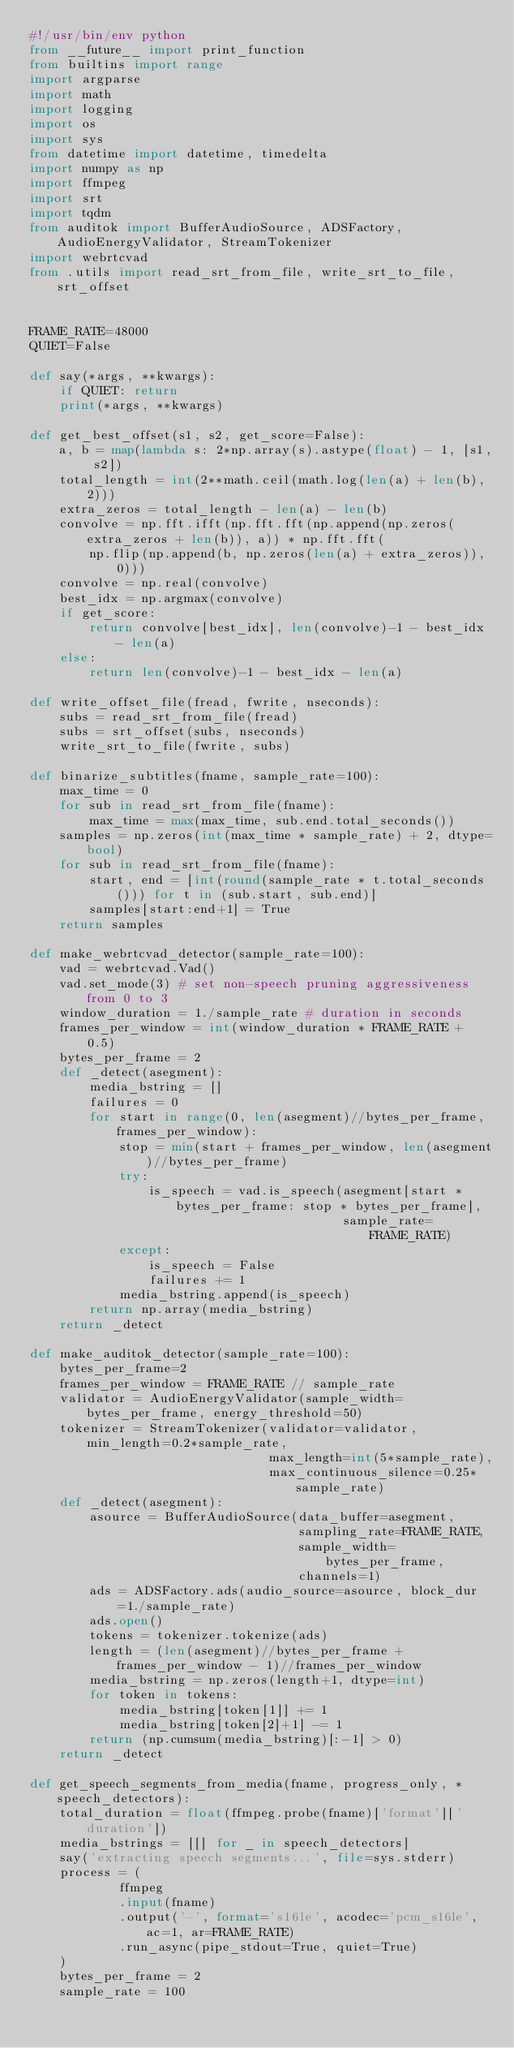Convert code to text. <code><loc_0><loc_0><loc_500><loc_500><_Python_>#!/usr/bin/env python
from __future__ import print_function
from builtins import range
import argparse
import math
import logging
import os
import sys
from datetime import datetime, timedelta
import numpy as np
import ffmpeg
import srt
import tqdm
from auditok import BufferAudioSource, ADSFactory, AudioEnergyValidator, StreamTokenizer
import webrtcvad
from .utils import read_srt_from_file, write_srt_to_file, srt_offset


FRAME_RATE=48000
QUIET=False

def say(*args, **kwargs):
    if QUIET: return
    print(*args, **kwargs)

def get_best_offset(s1, s2, get_score=False):
    a, b = map(lambda s: 2*np.array(s).astype(float) - 1, [s1, s2])
    total_length = int(2**math.ceil(math.log(len(a) + len(b), 2)))
    extra_zeros = total_length - len(a) - len(b)
    convolve = np.fft.ifft(np.fft.fft(np.append(np.zeros(extra_zeros + len(b)), a)) * np.fft.fft(
        np.flip(np.append(b, np.zeros(len(a) + extra_zeros)), 0)))
    convolve = np.real(convolve)
    best_idx = np.argmax(convolve)
    if get_score:
        return convolve[best_idx], len(convolve)-1 - best_idx - len(a)
    else:
        return len(convolve)-1 - best_idx - len(a)

def write_offset_file(fread, fwrite, nseconds):
    subs = read_srt_from_file(fread)
    subs = srt_offset(subs, nseconds)
    write_srt_to_file(fwrite, subs)

def binarize_subtitles(fname, sample_rate=100):
    max_time = 0
    for sub in read_srt_from_file(fname):
        max_time = max(max_time, sub.end.total_seconds())
    samples = np.zeros(int(max_time * sample_rate) + 2, dtype=bool)
    for sub in read_srt_from_file(fname):
        start, end = [int(round(sample_rate * t.total_seconds())) for t in (sub.start, sub.end)]
        samples[start:end+1] = True
    return samples

def make_webrtcvad_detector(sample_rate=100):
    vad = webrtcvad.Vad()
    vad.set_mode(3) # set non-speech pruning aggressiveness from 0 to 3
    window_duration = 1./sample_rate # duration in seconds
    frames_per_window = int(window_duration * FRAME_RATE + 0.5)
    bytes_per_frame = 2
    def _detect(asegment):
        media_bstring = []
        failures = 0
        for start in range(0, len(asegment)//bytes_per_frame, frames_per_window):
            stop = min(start + frames_per_window, len(asegment)//bytes_per_frame)
            try:
                is_speech = vad.is_speech(asegment[start * bytes_per_frame: stop * bytes_per_frame],
                                          sample_rate=FRAME_RATE)
            except:
                is_speech = False
                failures += 1
            media_bstring.append(is_speech)
        return np.array(media_bstring)
    return _detect

def make_auditok_detector(sample_rate=100):
    bytes_per_frame=2
    frames_per_window = FRAME_RATE // sample_rate
    validator = AudioEnergyValidator(sample_width=bytes_per_frame, energy_threshold=50)
    tokenizer = StreamTokenizer(validator=validator, min_length=0.2*sample_rate,
                                max_length=int(5*sample_rate),
                                max_continuous_silence=0.25*sample_rate)
    def _detect(asegment):
        asource = BufferAudioSource(data_buffer=asegment,
                                    sampling_rate=FRAME_RATE,
                                    sample_width=bytes_per_frame,
                                    channels=1)
        ads = ADSFactory.ads(audio_source=asource, block_dur=1./sample_rate)
        ads.open()
        tokens = tokenizer.tokenize(ads)
        length = (len(asegment)//bytes_per_frame + frames_per_window - 1)//frames_per_window
        media_bstring = np.zeros(length+1, dtype=int)
        for token in tokens:
            media_bstring[token[1]] += 1
            media_bstring[token[2]+1] -= 1
        return (np.cumsum(media_bstring)[:-1] > 0)
    return _detect

def get_speech_segments_from_media(fname, progress_only, *speech_detectors):
    total_duration = float(ffmpeg.probe(fname)['format']['duration'])
    media_bstrings = [[] for _ in speech_detectors]
    say('extracting speech segments...', file=sys.stderr)
    process = (
            ffmpeg
            .input(fname)
            .output('-', format='s16le', acodec='pcm_s16le', ac=1, ar=FRAME_RATE)
            .run_async(pipe_stdout=True, quiet=True)
    )
    bytes_per_frame = 2
    sample_rate = 100</code> 